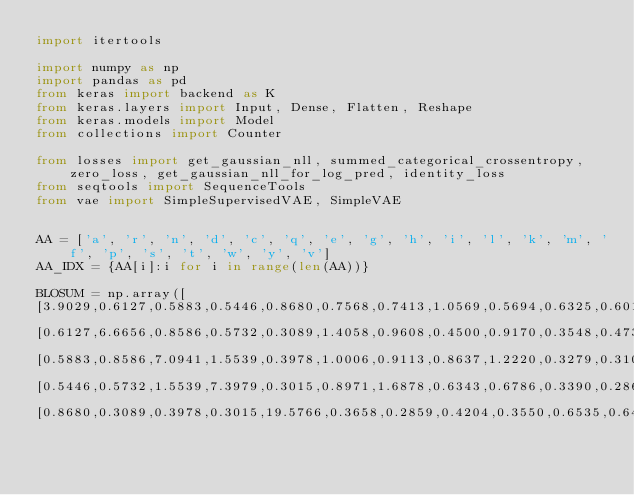<code> <loc_0><loc_0><loc_500><loc_500><_Python_>import itertools

import numpy as np
import pandas as pd
from keras import backend as K
from keras.layers import Input, Dense, Flatten, Reshape
from keras.models import Model
from collections import Counter

from losses import get_gaussian_nll, summed_categorical_crossentropy, zero_loss, get_gaussian_nll_for_log_pred, identity_loss
from seqtools import SequenceTools
from vae import SimpleSupervisedVAE, SimpleVAE


AA = ['a', 'r', 'n', 'd', 'c', 'q', 'e', 'g', 'h', 'i', 'l', 'k', 'm', 'f', 'p', 's', 't', 'w', 'y', 'v']
AA_IDX = {AA[i]:i for i in range(len(AA))}

BLOSUM = np.array([
[3.9029,0.6127,0.5883,0.5446,0.8680,0.7568,0.7413,1.0569,0.5694,0.6325,0.6019,0.7754,0.7232,0.4649,0.7541,1.4721,0.9844,0.4165,0.5426,0.9365],
[0.6127,6.6656,0.8586,0.5732,0.3089,1.4058,0.9608,0.4500,0.9170,0.3548,0.4739,2.0768,0.6226,0.3807,0.4815,0.7672,0.6778,0.3951,0.5560,0.4201],
[0.5883,0.8586,7.0941,1.5539,0.3978,1.0006,0.9113,0.8637,1.2220,0.3279,0.3100,0.9398,0.4745,0.3543,0.4999,1.2315,0.9842,0.2778,0.4860,0.3690],
[0.5446,0.5732,1.5539,7.3979,0.3015,0.8971,1.6878,0.6343,0.6786,0.3390,0.2866,0.7841,0.3465,0.2990,0.5987,0.9135,0.6948,0.2321,0.3457,0.3365],
[0.8680,0.3089,0.3978,0.3015,19.5766,0.3658,0.2859,0.4204,0.3550,0.6535,0.6423,0.3491,0.6114,0.4390,0.3796,0.7384,0.7406,0.4500,0.4342,0.7558],</code> 